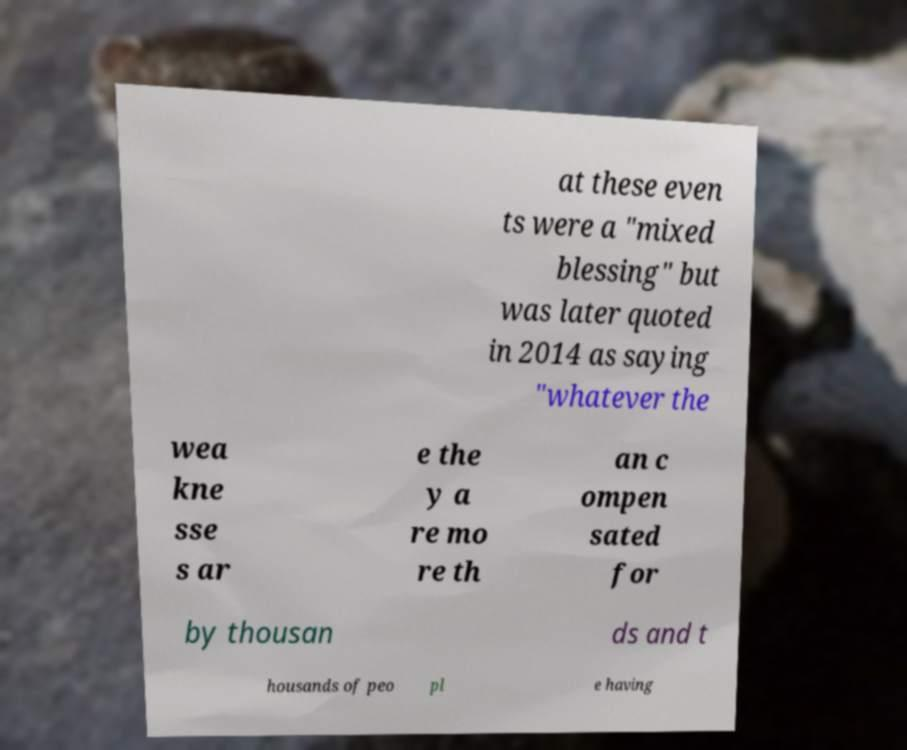I need the written content from this picture converted into text. Can you do that? at these even ts were a "mixed blessing" but was later quoted in 2014 as saying "whatever the wea kne sse s ar e the y a re mo re th an c ompen sated for by thousan ds and t housands of peo pl e having 